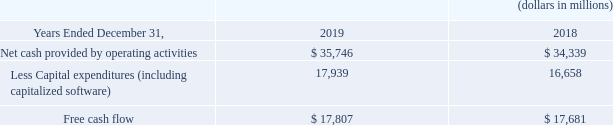Free Cash Flow
Free cash flow is a non-GAAP financial measure that reflects an additional way of viewing our liquidity that, when viewed with our GAAP results, provides a more complete understanding of factors and trends affecting our cash flows. Free cash flow is calculated by subtracting capital expenditures from net cash provided by operating activities. We believe it is a more conservative measure of cash flow since purchases of fixed assets are necessary for ongoing operations.
Free cash flow has limitations due to the fact that it does not represent the residual cash flow available for discretionary expenditures. For example, free cash flow does not incorporate payments made on finance lease obligations or cash payments for business acquisitions or wireless licenses. Therefore, we believe it is important to view free cash flow as a complement to our entire consolidated statements of cash flows.
The following table reconciles net cash provided by operating activities to Free cash flow:
The increase in free cash flow during 2019 is a reflection of the increase in operating cash flows, partially offset by the increase in capital expenditures discussed above.
How is free cash flow calculated? By subtracting capital expenditures from net cash provided by operating activities. we believe it is a more conservative measure of cash flow since purchases of fixed assets are necessary for ongoing operations. What was the Less Capital expenditures (including capitalized software) in 2019?
Answer scale should be: million. 17,939. What was the free cash flow in 2019?
Answer scale should be: million. $ 17,807. What was the change in the net cash provided by operating activities from 2018 to 2019?
Answer scale should be: million. 35,746 - 34,339
Answer: 1407. What was the average free cash flow for 2018 and 2019?
Answer scale should be: million. (17,807 + 17,681) / 2
Answer: 17744. What was the percentage change in the Less Capital expenditures from 2018 to 2019?
Answer scale should be: percent. 17,939 / 16,658 - 1
Answer: 7.69. 